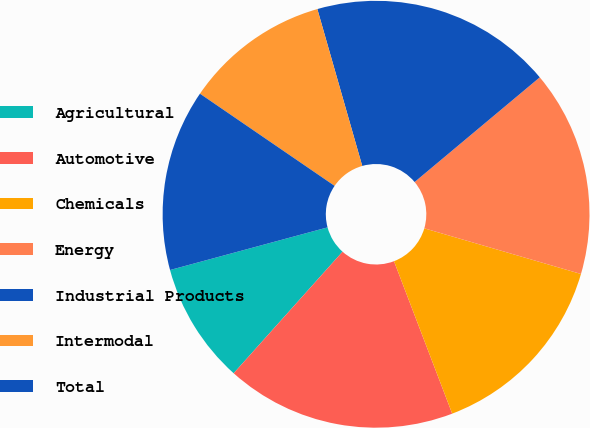Convert chart to OTSL. <chart><loc_0><loc_0><loc_500><loc_500><pie_chart><fcel>Agricultural<fcel>Automotive<fcel>Chemicals<fcel>Energy<fcel>Industrial Products<fcel>Intermodal<fcel>Total<nl><fcel>9.17%<fcel>17.43%<fcel>14.68%<fcel>15.6%<fcel>18.35%<fcel>11.01%<fcel>13.76%<nl></chart> 